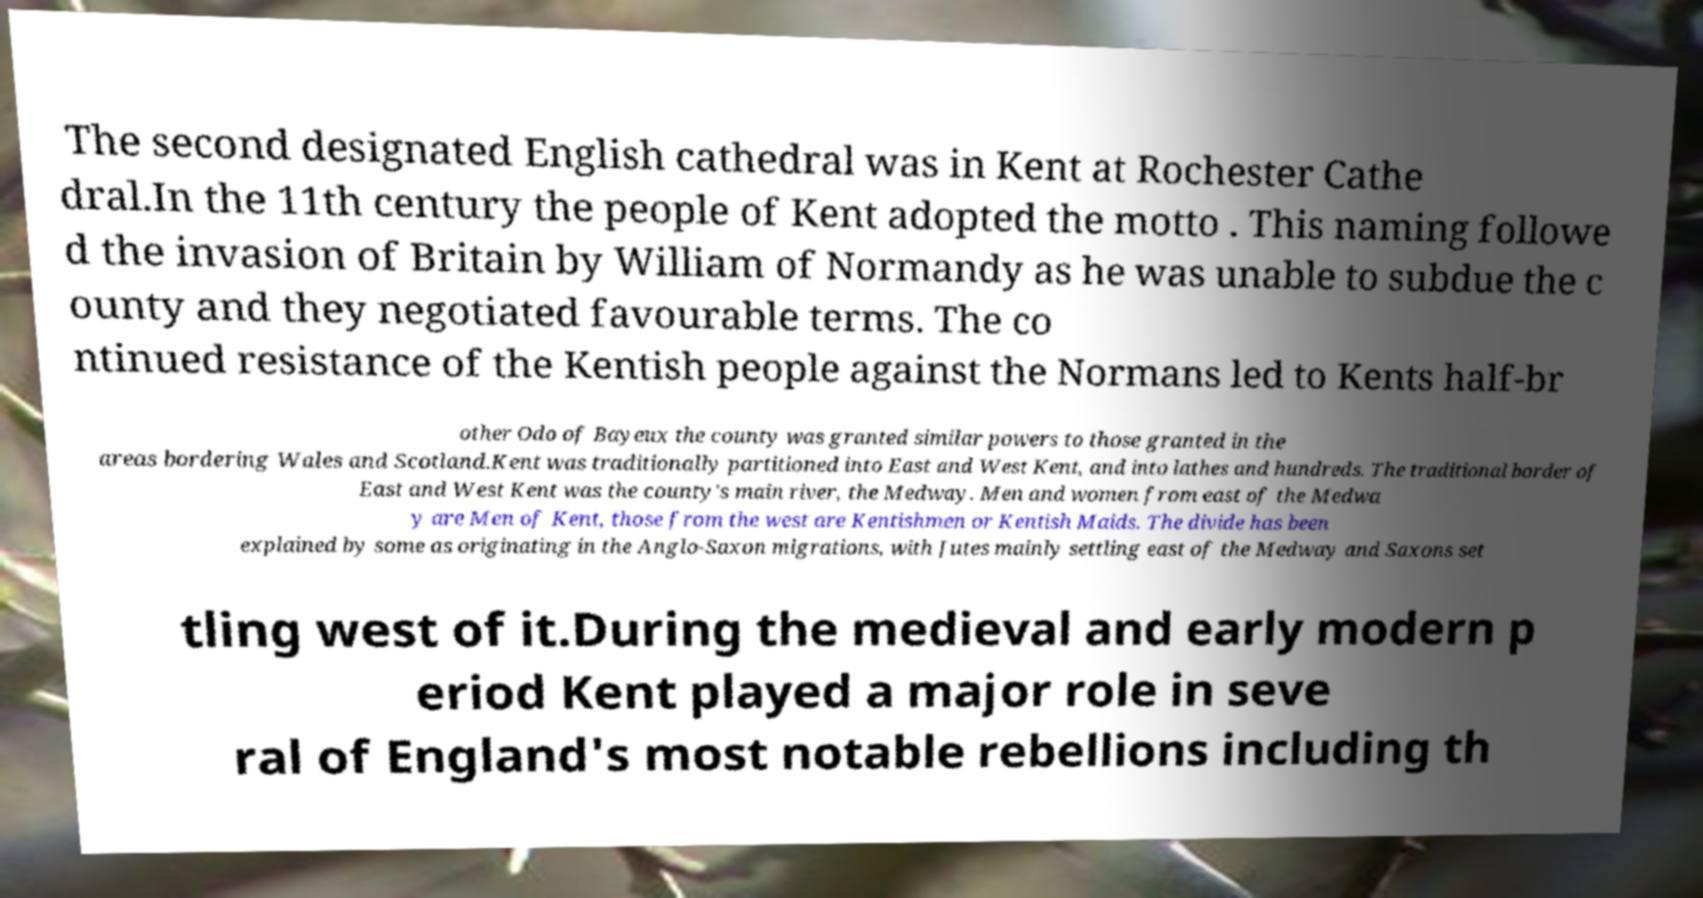There's text embedded in this image that I need extracted. Can you transcribe it verbatim? The second designated English cathedral was in Kent at Rochester Cathe dral.In the 11th century the people of Kent adopted the motto . This naming followe d the invasion of Britain by William of Normandy as he was unable to subdue the c ounty and they negotiated favourable terms. The co ntinued resistance of the Kentish people against the Normans led to Kents half-br other Odo of Bayeux the county was granted similar powers to those granted in the areas bordering Wales and Scotland.Kent was traditionally partitioned into East and West Kent, and into lathes and hundreds. The traditional border of East and West Kent was the county's main river, the Medway. Men and women from east of the Medwa y are Men of Kent, those from the west are Kentishmen or Kentish Maids. The divide has been explained by some as originating in the Anglo-Saxon migrations, with Jutes mainly settling east of the Medway and Saxons set tling west of it.During the medieval and early modern p eriod Kent played a major role in seve ral of England's most notable rebellions including th 